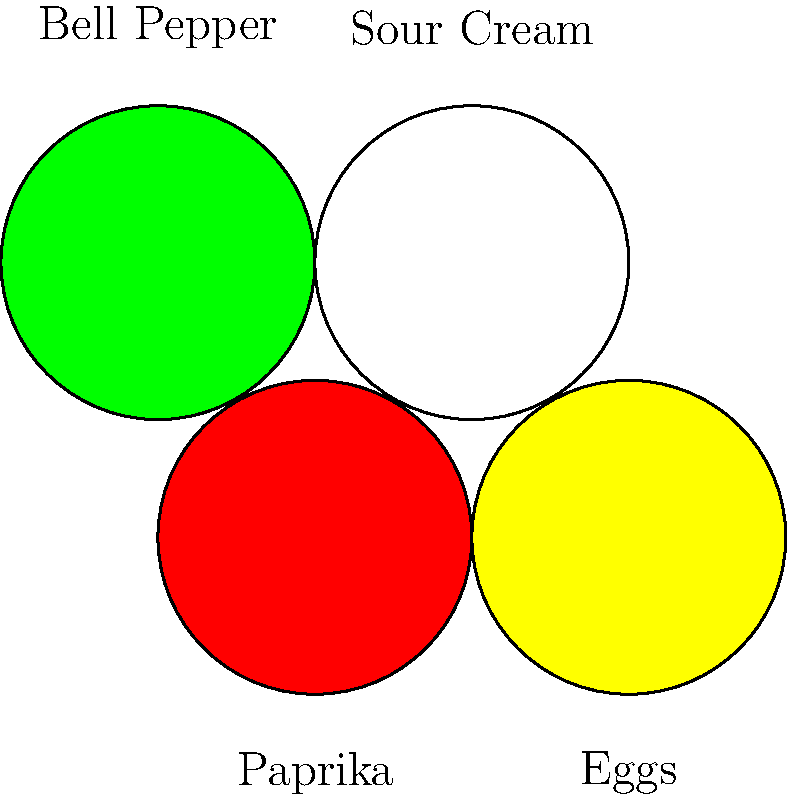Based on the visual representation of ingredients, which traditional Hungarian dish is most likely being prepared? To identify the Hungarian dish, let's analyze the ingredients shown:

1. Paprika (red circle): A key spice in Hungarian cuisine, often used for flavor and color.
2. Eggs (yellow circle): Suggests a dish that incorporates eggs as a main ingredient.
3. Bell Pepper (green circle): A common vegetable in Hungarian cooking, often used in stews and sautéed dishes.
4. Sour Cream (white circle): A staple in Hungarian cuisine, used to add creaminess and tang to many dishes.

Considering these ingredients together, we can deduce that the dish being prepared is likely Lecsó. This traditional Hungarian stew typically includes:

- Sautéed bell peppers
- Tomatoes (not shown, but often used with bell peppers)
- Eggs (added towards the end of cooking)
- Paprika for seasoning
- Sometimes served with a dollop of sour cream

While there are variations, the combination of bell peppers, eggs, paprika, and sour cream strongly indicates Lecsó, a popular summer dish in Hungary.
Answer: Lecsó 